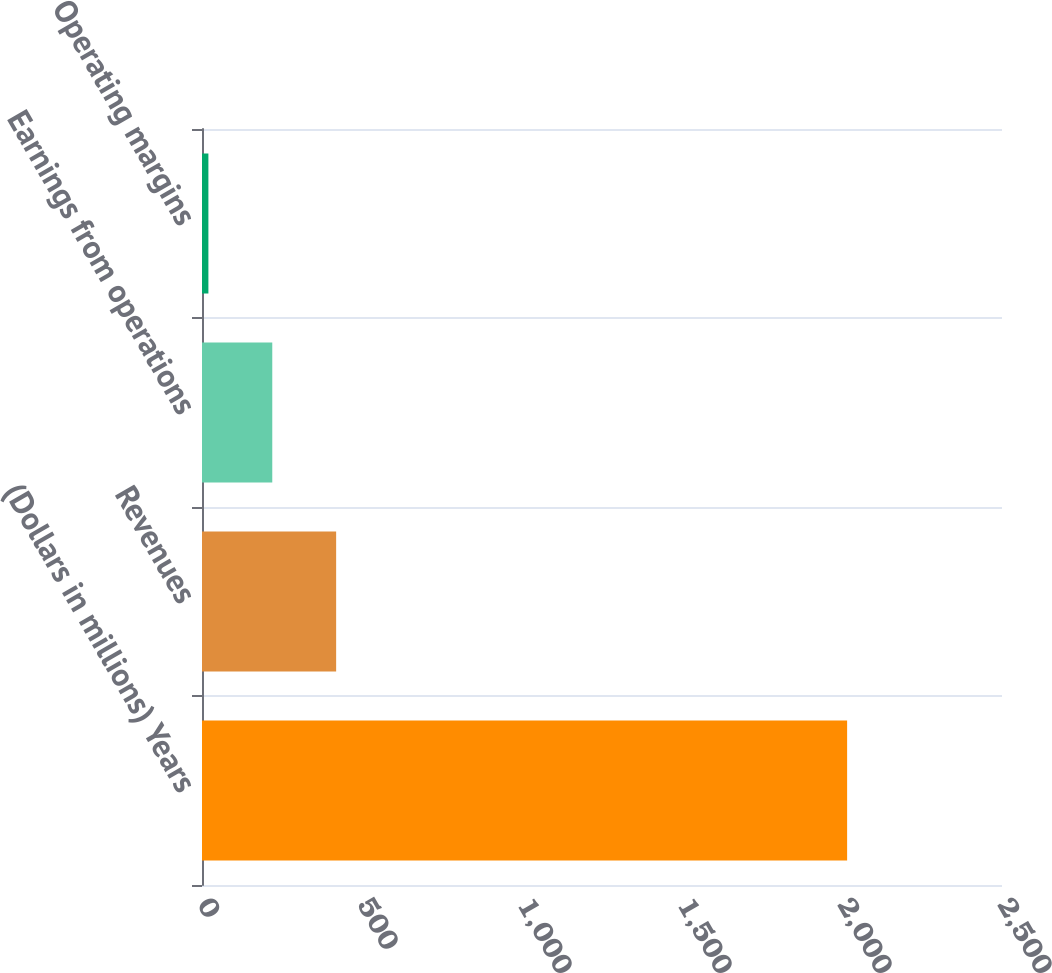Convert chart to OTSL. <chart><loc_0><loc_0><loc_500><loc_500><bar_chart><fcel>(Dollars in millions) Years<fcel>Revenues<fcel>Earnings from operations<fcel>Operating margins<nl><fcel>2016<fcel>419.2<fcel>219.6<fcel>20<nl></chart> 